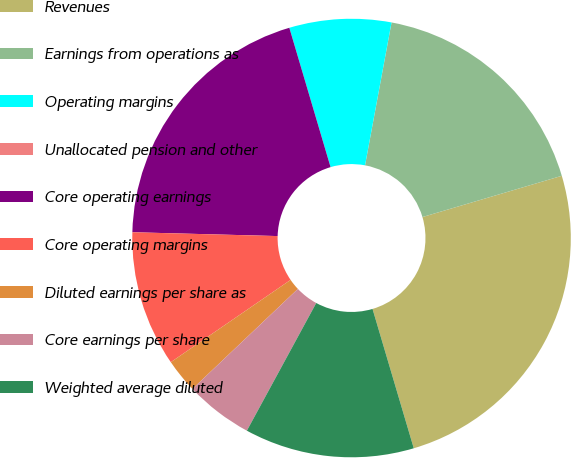Convert chart. <chart><loc_0><loc_0><loc_500><loc_500><pie_chart><fcel>Revenues<fcel>Earnings from operations as<fcel>Operating margins<fcel>Unallocated pension and other<fcel>Core operating earnings<fcel>Core operating margins<fcel>Diluted earnings per share as<fcel>Core earnings per share<fcel>Weighted average diluted<nl><fcel>25.0%<fcel>17.5%<fcel>7.5%<fcel>0.0%<fcel>20.0%<fcel>10.0%<fcel>2.5%<fcel>5.0%<fcel>12.5%<nl></chart> 